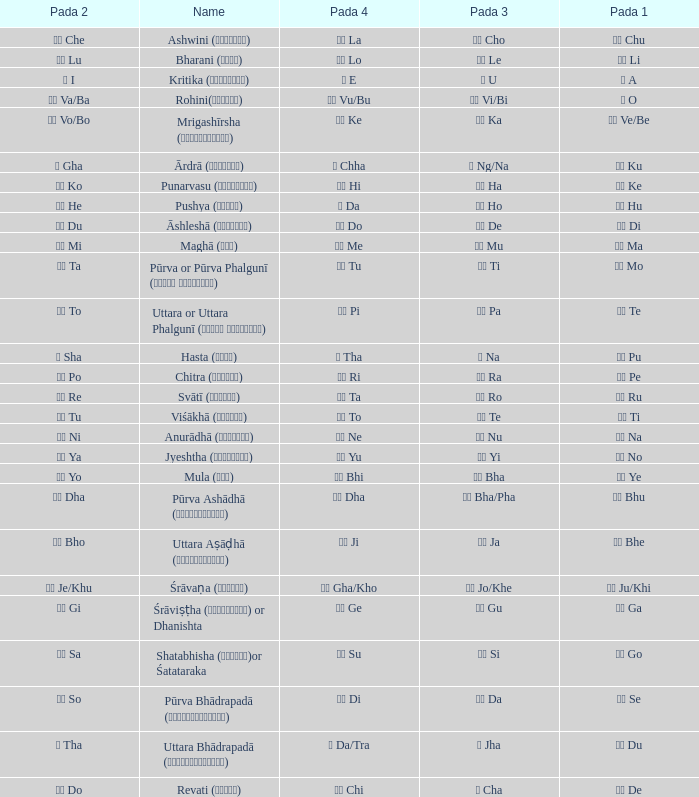Which Pada 3 has a Pada 1 of टे te? पा Pa. 